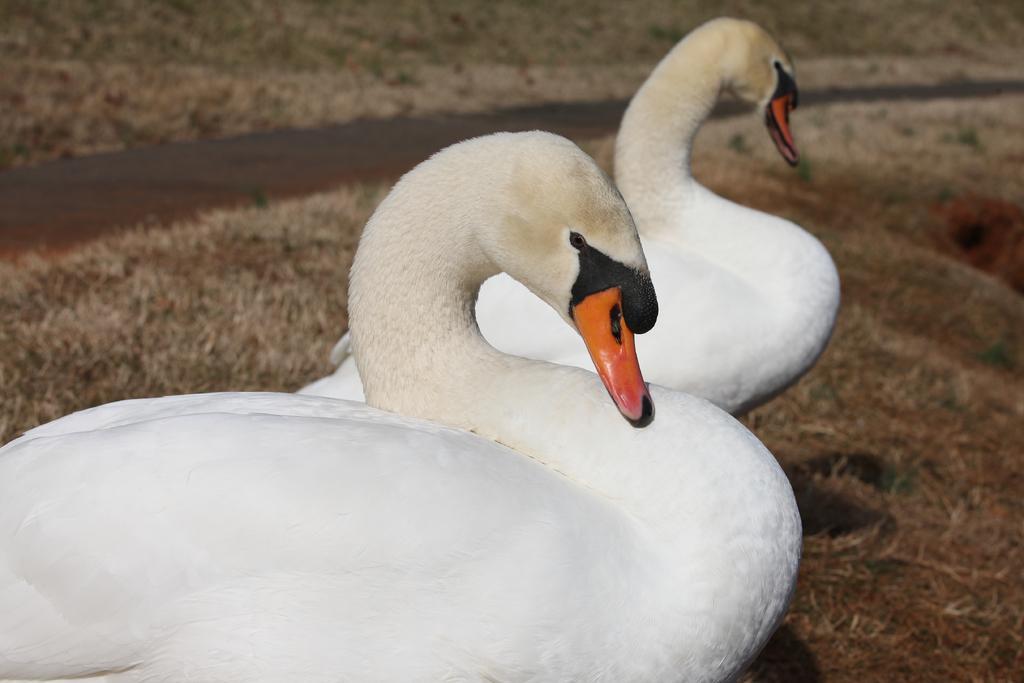Describe this image in one or two sentences. In this image I can see two swans facing towards the right side. At the bottom, I can see the grass. On the left side there is a lake. 